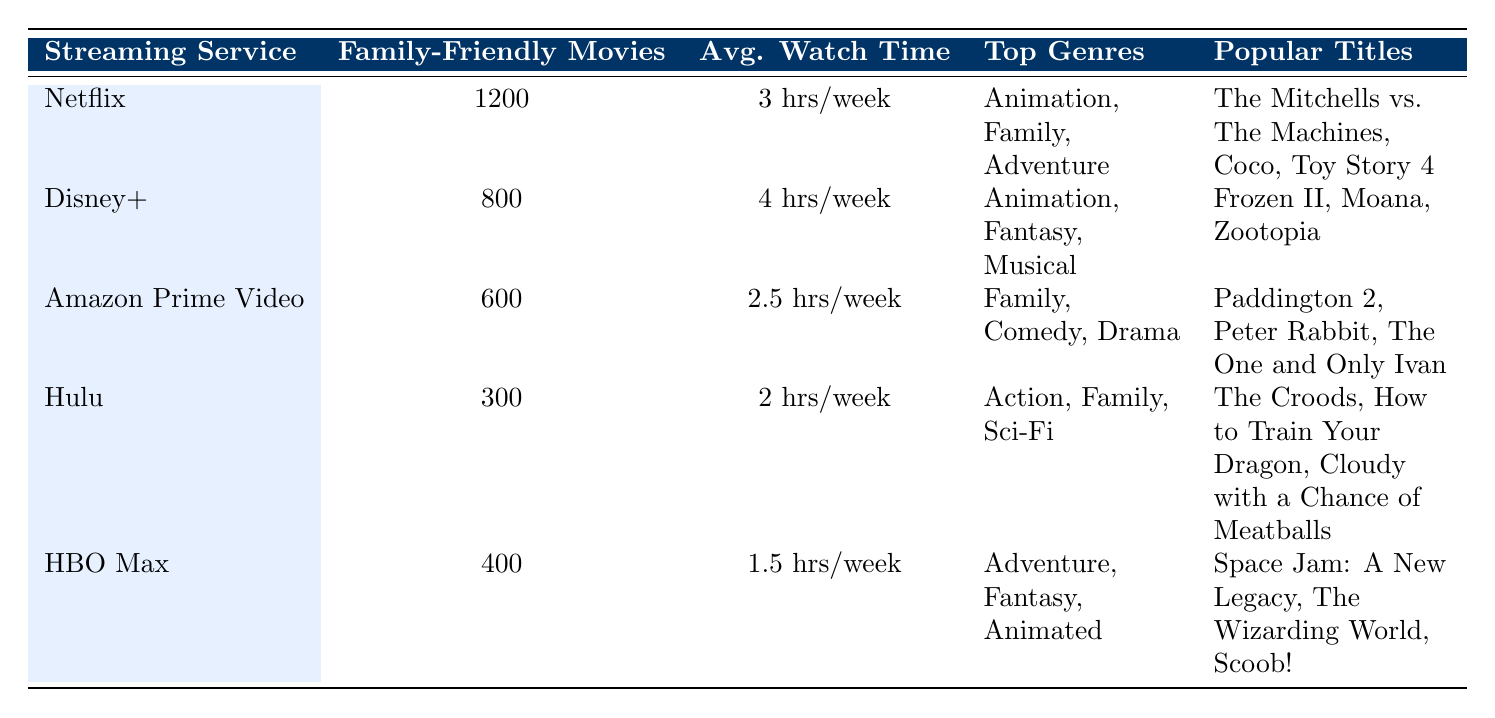What is the family-friendly movie count for Netflix? The table directly states that Netflix has 1200 family-friendly movies.
Answer: 1200 Which streaming service has the highest average watch time per family? By comparing the "Avg. Watch Time" column, Disney+ has the highest average of 4 hours per week.
Answer: Disney+ Is Hulu's average watch time greater than that of Amazon Prime Video? Hulu's average watch time is 2 hours/week, and Amazon Prime Video's is 2.5 hours/week. Since 2 hours is less than 2.5 hours, the statement is false.
Answer: No What are the top genres for Amazon Prime Video? The table lists the top genres for Amazon Prime Video as Family, Comedy, and Drama.
Answer: Family, Comedy, Drama How many more family-friendly movies does Netflix have compared to Hulu? Netflix has 1200 family-friendly movies, and Hulu has 300. The difference is 1200 - 300 = 900.
Answer: 900 What is the average number of family-friendly movies across all streaming services listed? To find the average, sum up all family-friendly movies: 1200 + 800 + 600 + 300 + 400 = 3300, and divide by the number of services (5): 3300 / 5 = 660.
Answer: 660 True or False: HBO Max has more family-friendly movies than Hulu. HBO Max has 400 family-friendly movies, and Hulu has 300, making the statement true.
Answer: Yes Which streaming service has the least amount of family-friendly movies? By reviewing the family-friendly movie counts, Hulu has the least at 300.
Answer: Hulu Name a popular title on Disney+. The table lists popular titles for Disney+ including Frozen II, Moana, and Zootopia. Any one of these would be a correct answer.
Answer: Frozen II 